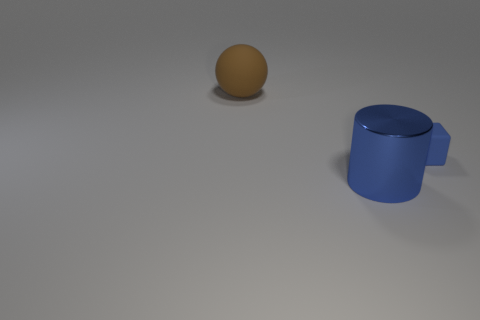Is there anything else that is the same material as the big brown object?
Your answer should be very brief. Yes. There is a big thing that is behind the blue object that is in front of the small thing; are there any blue cylinders behind it?
Your answer should be very brief. No. What number of big objects are either brown rubber things or cubes?
Your response must be concise. 1. Is there any other thing that is the same color as the big sphere?
Offer a terse response. No. Is the size of the blue thing left of the blue block the same as the block?
Provide a short and direct response. No. What is the color of the thing that is on the left side of the blue thing on the left side of the matte thing on the right side of the brown matte thing?
Provide a short and direct response. Brown. The metallic thing is what color?
Give a very brief answer. Blue. Does the large cylinder have the same color as the small block?
Your response must be concise. Yes. Are the object that is in front of the cube and the blue object right of the shiny cylinder made of the same material?
Your answer should be very brief. No. Is the material of the brown ball the same as the small blue cube?
Your response must be concise. Yes. 